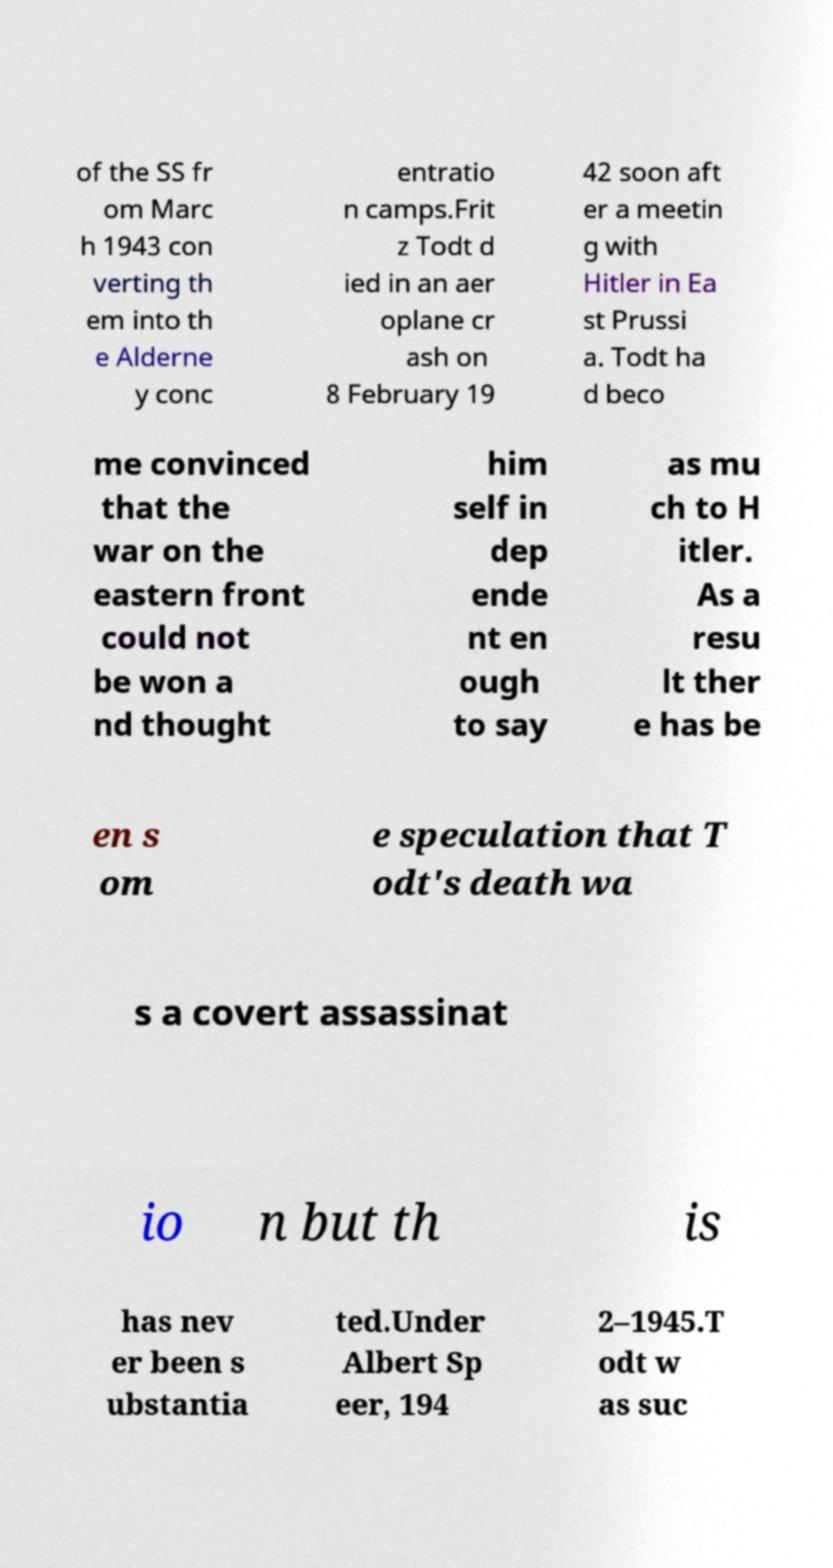Please identify and transcribe the text found in this image. of the SS fr om Marc h 1943 con verting th em into th e Alderne y conc entratio n camps.Frit z Todt d ied in an aer oplane cr ash on 8 February 19 42 soon aft er a meetin g with Hitler in Ea st Prussi a. Todt ha d beco me convinced that the war on the eastern front could not be won a nd thought him self in dep ende nt en ough to say as mu ch to H itler. As a resu lt ther e has be en s om e speculation that T odt's death wa s a covert assassinat io n but th is has nev er been s ubstantia ted.Under Albert Sp eer, 194 2–1945.T odt w as suc 